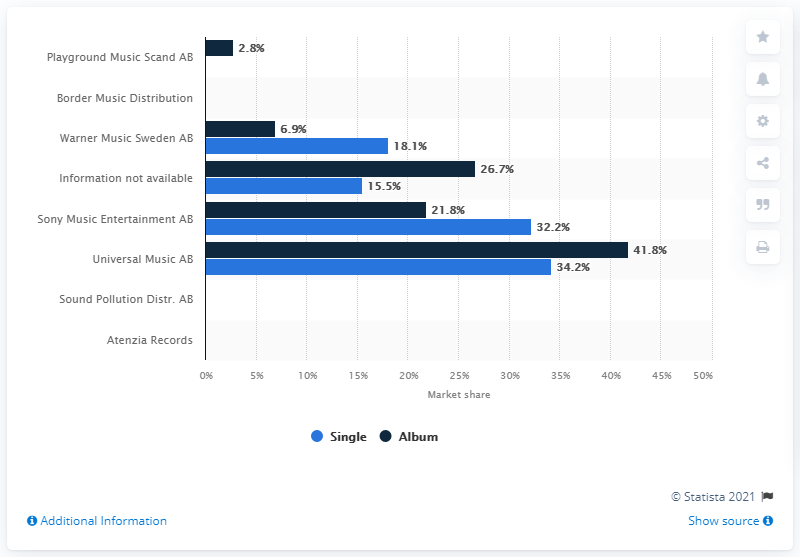Outline some significant characteristics in this image. In June 2021, Sony's market share was 21.8%. 